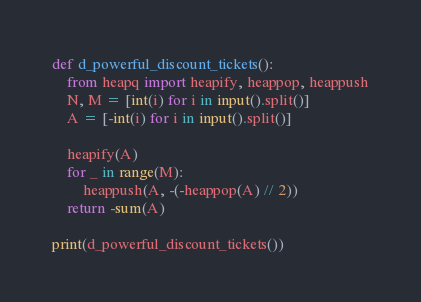Convert code to text. <code><loc_0><loc_0><loc_500><loc_500><_Python_>def d_powerful_discount_tickets():
    from heapq import heapify, heappop, heappush
    N, M = [int(i) for i in input().split()]
    A = [-int(i) for i in input().split()]

    heapify(A)
    for _ in range(M):
        heappush(A, -(-heappop(A) // 2))
    return -sum(A)

print(d_powerful_discount_tickets())</code> 